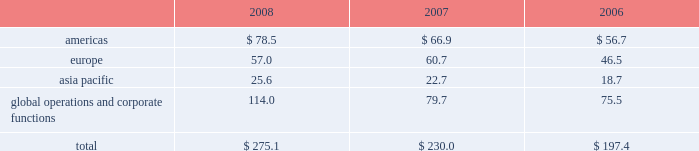Depreciation and amortization included in operating segment profit for the years ended december 31 , 2008 , 2007 and 2006 was as follows ( in millions ) : .
15 .
Leases future minimum rental commitments under non- cancelable operating leases in effect as of december 31 , 2008 were $ 38.2 million for 2009 , $ 30.1 million for 2010 , $ 20.9 million for 2011 , $ 15.9 million for 2012 , $ 14.3 million for 2013 and $ 29.9 million thereafter .
Total rent expense for the years ended december 31 , 2008 , 2007 and 2006 aggregated $ 41.4 million , $ 37.1 million and $ 31.1 million , respectively .
16 .
Commitments and contingencies intellectual property and product liability-related litigation in july 2008 , we temporarily suspended marketing and distribution of the durom bb acetabular component ( durom cup ) in the u.s .
To allow us to update product labeling to provide more detailed surgical technique instructions to surgeons and implement a surgical training program in the u.s .
Following our announcement , product liability lawsuits and other claims have been asserted against us , some of which we have settled .
There are a number of claims still pending and we expect additional claims will be submitted .
We recorded a provision of $ 47.5 million in the third quarter of 2008 , representing management 2019s estimate of these durom cup-related claims .
We increased that provision by $ 21.5 million in the fourth quarter of 2008 .
The provision is limited to revisions within two years of an original surgery that occurred prior to july 2008 .
These parameters are consistent with our data which indicates that cup loosenings associated with surgical technique are most likely to occur within that time period .
Any claims received outside of these defined parameters will be managed in the normal course and reflected in our standard product liability accruals .
On february 15 , 2005 , howmedica osteonics corp .
Filed an action against us and an unrelated party in the united states district court for the district of new jersey alleging infringement of u.s .
Patent nos .
6174934 ; 6372814 ; 6664308 ; and 6818020 .
On june 13 , 2007 , the court granted our motion for summary judgment on the invalidity of the asserted claims of u.s .
Patent nos .
6174934 ; 6372814 ; and 6664308 by ruling that all of the asserted claims are invalid for indefiniteness .
On august 19 , 2008 , the court granted our motion for summary judgment of non- infringement of certain claims of u.s .
Patent no .
6818020 , reducing the number of claims at issue in the suit to five .
We continue to believe that our defenses against infringement of the remaining claims are valid and meritorious , and we intend to defend this lawsuit vigorously .
In addition to certain claims related to the durom cup discussed above , we are also subject to product liability and other claims and lawsuits arising in the ordinary course of business , for which we maintain insurance , subject to self- insured retention limits .
We establish accruals for product liability and other claims in conjunction with outside counsel based on current information and historical settlement information for open claims , related fees and claims incurred but not reported .
While it is not possible to predict with certainty the outcome of these cases , it is the opinion of management that , upon ultimate resolution , liabilities from these cases in excess of those recorded , if any , will not have a material adverse effect on our consolidated financial position , results of operations or cash flows .
Government investigations in march 2005 , the u.s .
Department of justice through the u.s .
Attorney 2019s office in newark , new jersey commenced an investigation of us and four other orthopaedic companies pertaining to consulting contracts , professional service agreements and other agreements by which remuneration is provided to orthopaedic surgeons .
On september 27 , 2007 , we reached a settlement with the government to resolve all claims related to this investigation .
As part of the settlement , we entered into a settlement agreement with the u.s .
Through the u.s .
Department of justice and the office of inspector general of the department of health and human services ( the 201coig-hhs 201d ) .
In addition , we entered into a deferred prosecution agreement ( the 201cdpa 201d ) with the u.s .
Attorney 2019s office for the district of new jersey ( the 201cu.s .
Attorney 201d ) and a corporate integrity agreement ( the 201ccia 201d ) with the oig- hhs .
We did not admit any wrongdoing , plead guilty to any criminal charges or pay any criminal fines as part of the settlement .
We settled all civil and administrative claims related to the federal investigation by making a settlement payment to the u.s .
Government of $ 169.5 million .
Under the terms of the dpa , the u.s .
Attorney filed a criminal complaint in the u.s .
District court for the district of new jersey charging us with conspiracy to commit violations of the anti-kickback statute ( 42 u.s.c .
A7 1320a-7b ) during the years 2002 through 2006 .
The court deferred prosecution of the criminal complaint during the 18-month term of the dpa .
The u.s .
Attorney will seek dismissal of the criminal complaint after the 18-month period if we comply with the provisions of the dpa .
The dpa provides for oversight by a federally-appointed monitor .
Under the cia , which has a term of five years , we agreed , among other provisions , to continue the operation of our enhanced corporate compliance program , designed to promote compliance with federal healthcare program z i m m e r h o l d i n g s , i n c .
2 0 0 8 f o r m 1 0 - k a n n u a l r e p o r t notes to consolidated financial statements ( continued ) %%transmsg*** transmitting job : c48761 pcn : 060000000 ***%%pcmsg|60 |00012|yes|no|02/24/2009 06:10|0|0|page is valid , no graphics -- color : d| .
In 2008 , america's total depreciation & amortization is what percent of europe and asia combined? 
Rationale: shows balance of overall markets
Computations: (57.0 + 25.6)
Answer: 82.6. 